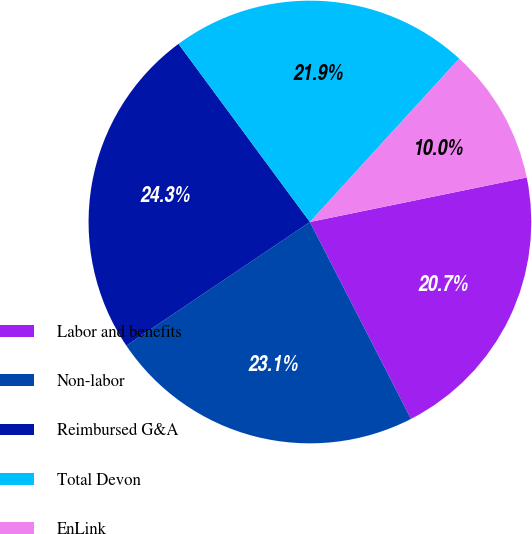<chart> <loc_0><loc_0><loc_500><loc_500><pie_chart><fcel>Labor and benefits<fcel>Non-labor<fcel>Reimbursed G&A<fcel>Total Devon<fcel>EnLink<nl><fcel>20.68%<fcel>23.11%<fcel>24.32%<fcel>21.9%<fcel>9.99%<nl></chart> 